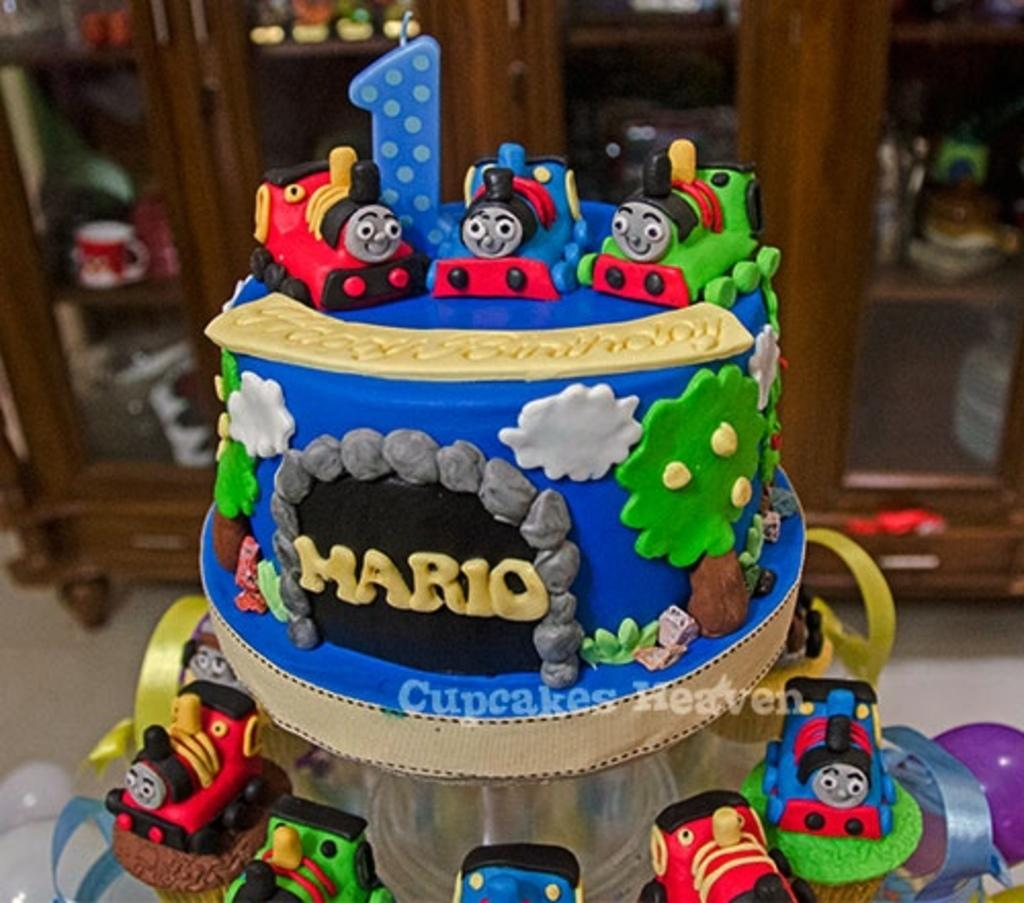What can be found inside the cupboards in the image? There are objects placed in cupboards in the image. What type of decoration is present in the image? There are balloons in the image. What is the main food item featured in the image? There is a cake in the image. What type of button is used to control the cake in the image? There is no button or control mechanism present in the image; it simply features a cake and balloons. What month is depicted in the image? The image does not depict a specific month or time of year. 